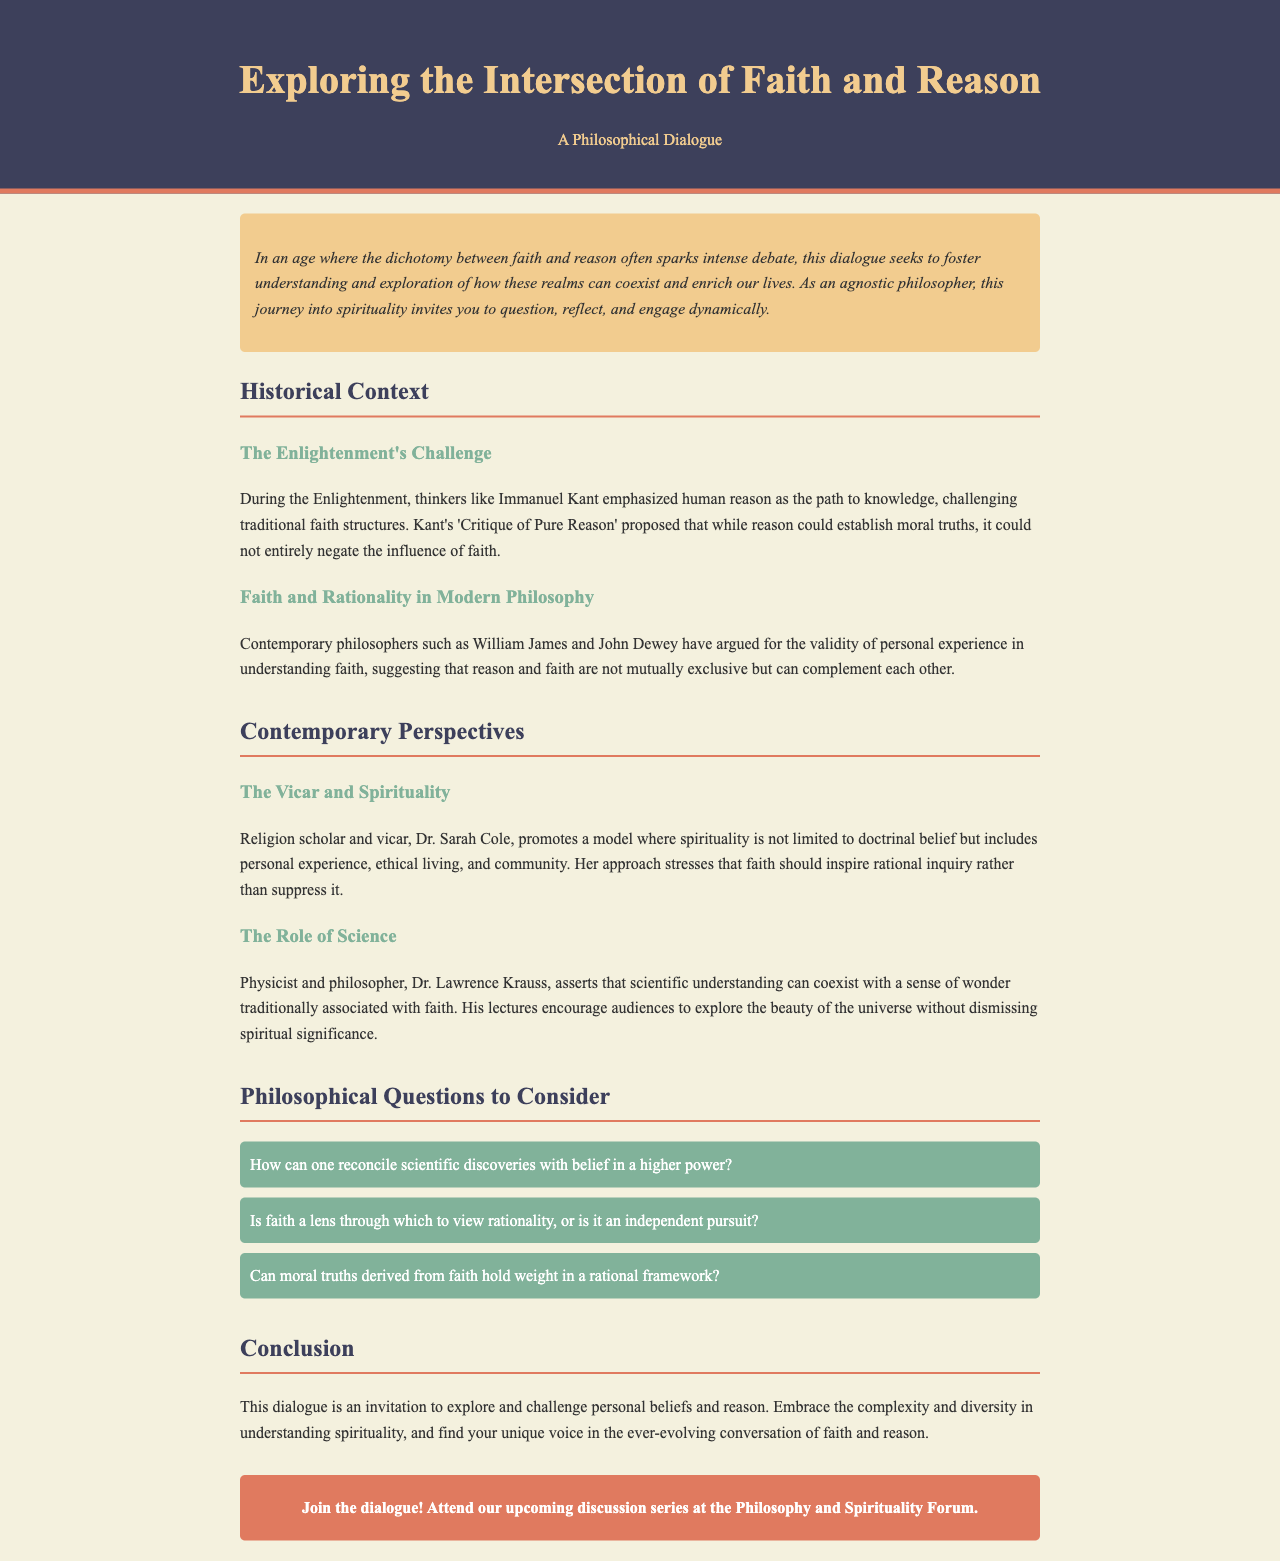What is the title of the document? The title is prominently displayed in the header of the document.
Answer: Exploring the Intersection of Faith and Reason Who wrote 'Critique of Pure Reason'? This is mentioned in the historical context under Enlightenment thinkers.
Answer: Immanuel Kant What is Dr. Sarah Cole's profession? The document identifies her role in the section about contemporary perspectives.
Answer: Religion scholar and vicar What does Dr. Lawrence Krauss encourage audiences to explore? This is outlined in the section discussing the role of science.
Answer: The beauty of the universe How many philosophical questions are presented in the document? The document lists three questions in the section dedicated to philosophical inquiries.
Answer: Three 